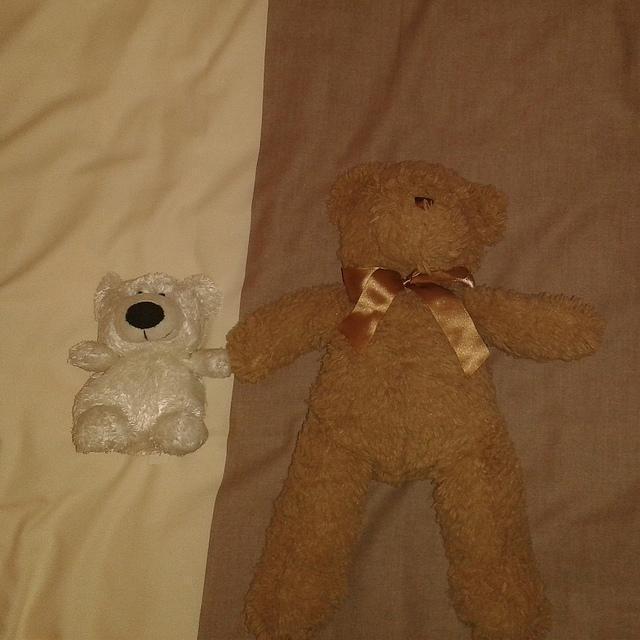How many teddy bears are there?
Give a very brief answer. 2. How many people are wearing helmet?
Give a very brief answer. 0. 